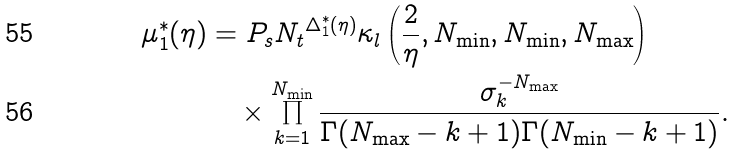<formula> <loc_0><loc_0><loc_500><loc_500>\mu ^ { * } _ { 1 } ( \eta ) & = P _ { s } { N _ { t } } ^ { \Delta ^ { * } _ { 1 } ( \eta ) } \kappa _ { l } \left ( \frac { 2 } { \eta } , N _ { \min } , N _ { \min } , N _ { \max } \right ) \\ & \quad \times \prod _ { k = 1 } ^ { N _ { \min } } \frac { \sigma _ { k } ^ { - N _ { \max } } } { \Gamma ( N _ { \max } - k + 1 ) \Gamma ( N _ { \min } - k + 1 ) } .</formula> 